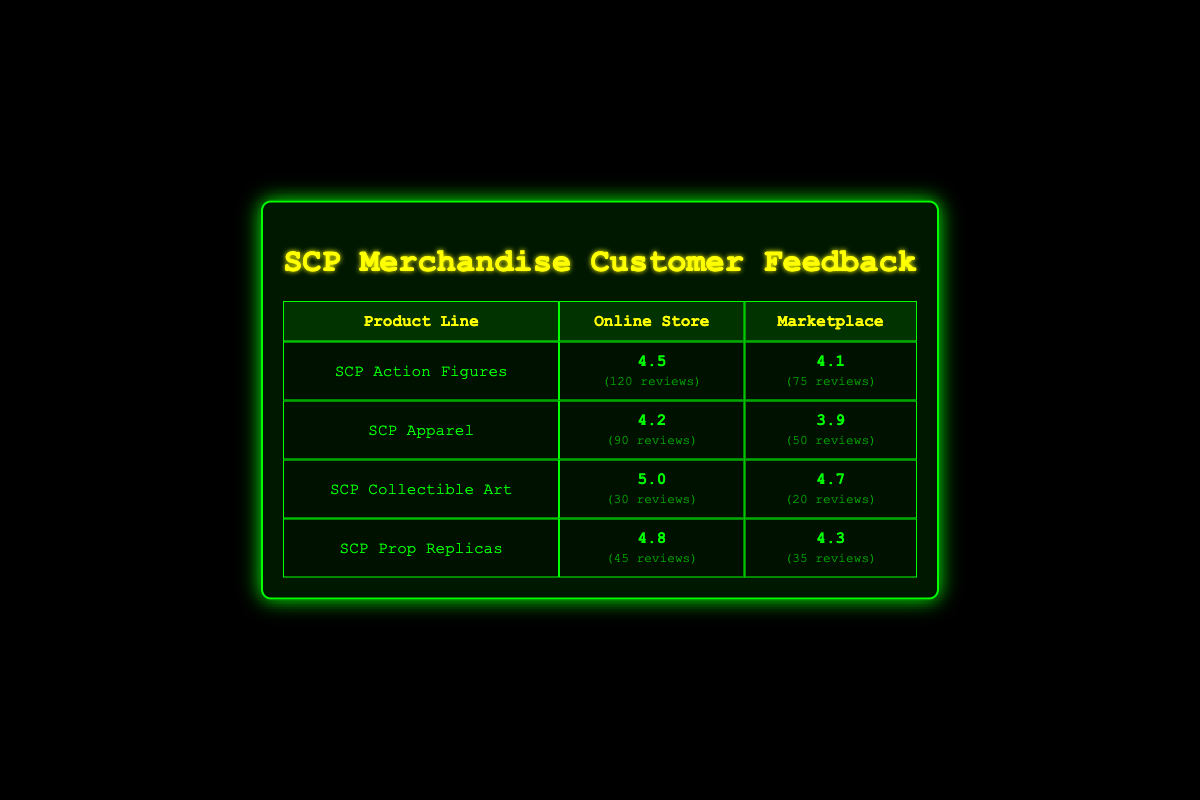What is the customer feedback rating for SCP Collectible Art sold in the Online Store? The customer's feedback rating for SCP Collectible Art in the Online Store is listed in the corresponding row and is 5.0.
Answer: 5.0 Which product line has the highest customer feedback rating in the Marketplace? For the Marketplace column, we compare the ratings: SCP Action Figures (4.1), SCP Apparel (3.9), SCP Collectible Art (4.7), and SCP Prop Replicas (4.3). The highest rating is 4.7 for SCP Collectible Art.
Answer: SCP Collectible Art How many reviews did SCP Apparel receive in the Online Store? The number of reviews for SCP Apparel is found in the Online Store column of the corresponding row, which shows 90 reviews.
Answer: 90 What is the average customer feedback rating for SCP Prop Replicas across both sales channels? To find the average, we first identify the ratings: 4.8 (Online Store) and 4.3 (Marketplace). We sum these ratings (4.8 + 4.3 = 9.1) and then divide by the number of sales channels (2), resulting in an average rating of 9.1/2 = 4.55.
Answer: 4.55 Is the customer feedback rating for SCP Apparel in the Marketplace higher than 4.0? The rating for SCP Apparel in the Marketplace is 3.9, which is less than 4.0, making the statement false.
Answer: No Which sales channel has a higher overall customer feedback rating for SCP Action Figures, and by how much? The ratings are 4.5 (Online Store) and 4.1 (Marketplace). The difference is calculated by subtracting the Marketplace rating from the Online Store rating (4.5 - 4.1 = 0.4). Therefore, the Online Store has a higher rating by 0.4.
Answer: Online Store by 0.4 How many total reviews were received for SCP Collectible Art across both sales channels? We add the number of reviews for SCP Collectible Art from both channels: 30 reviews from the Online Store and 20 reviews from the Marketplace, giving us a total of 30 + 20 = 50 reviews.
Answer: 50 What is the customer feedback rating for SCP Prop Replicas in the Online Store? The rating for SCP Prop Replicas in the Online Store is directly found in the corresponding row, which is 4.8.
Answer: 4.8 